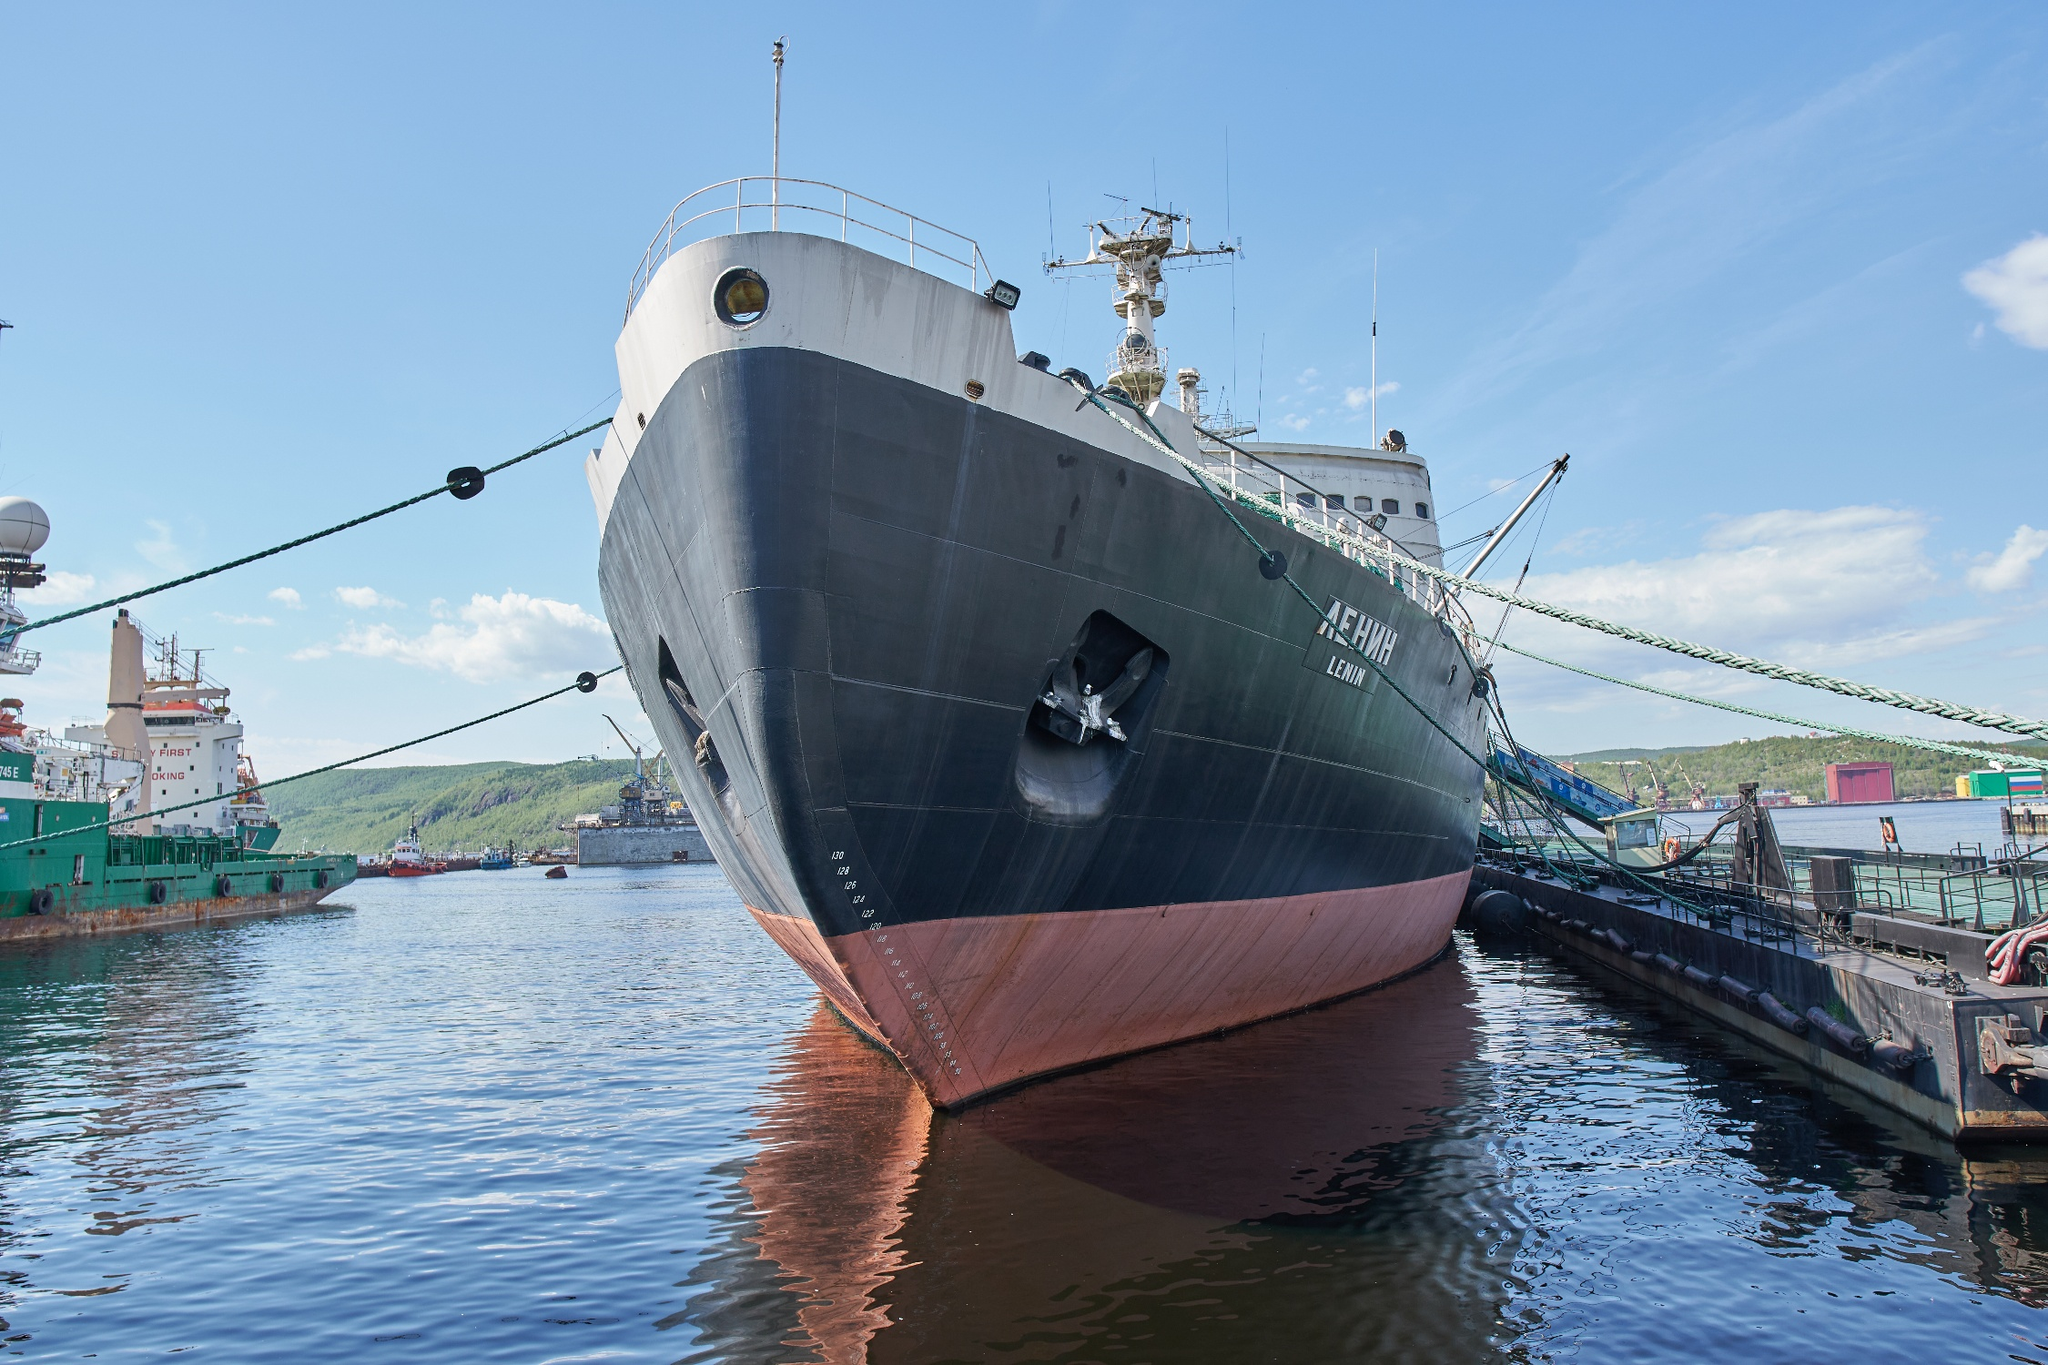Create a poetic description for this ship. Anchored firm in the harbor's embrace,
The Lenin rests, a sentinel of ice and grace.
Her hull of black, with history etched deep,
Silent stories of the Arctic it keeps.
Where the sky meets water, a bond unbroken,
By green lines tied, whispers of journeys token.
She stands, poised in a tranquil dance,
Awaiting once more to take a chance.
Vigor and valor forged in the cold,
A maritime saga in whispers told. 